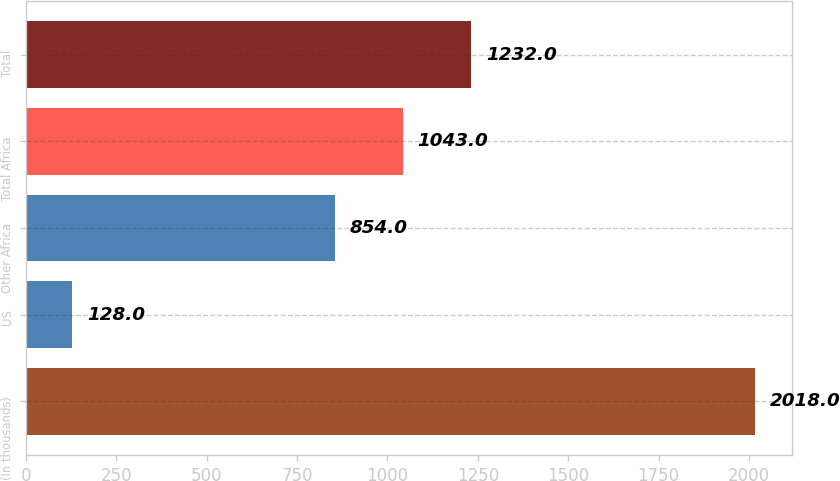<chart> <loc_0><loc_0><loc_500><loc_500><bar_chart><fcel>(In thousands)<fcel>US<fcel>Other Africa<fcel>Total Africa<fcel>Total<nl><fcel>2018<fcel>128<fcel>854<fcel>1043<fcel>1232<nl></chart> 